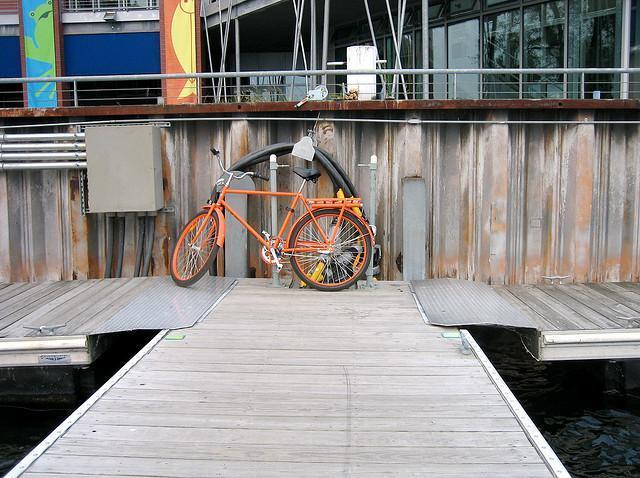How many bottles on the bar?
Give a very brief answer. 0. 